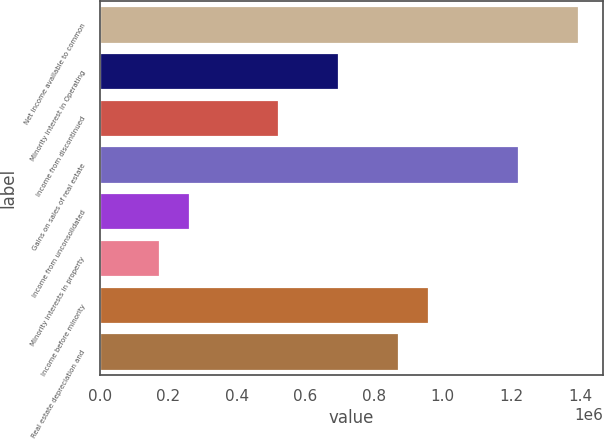Convert chart to OTSL. <chart><loc_0><loc_0><loc_500><loc_500><bar_chart><fcel>Net income available to common<fcel>Minority interest in Operating<fcel>Income from discontinued<fcel>Gains on sales of real estate<fcel>Income from unconsolidated<fcel>Minority interests in property<fcel>Income before minority<fcel>Real estate depreciation and<nl><fcel>1.39777e+06<fcel>698925<fcel>524215<fcel>1.22306e+06<fcel>262150<fcel>174795<fcel>960990<fcel>873635<nl></chart> 